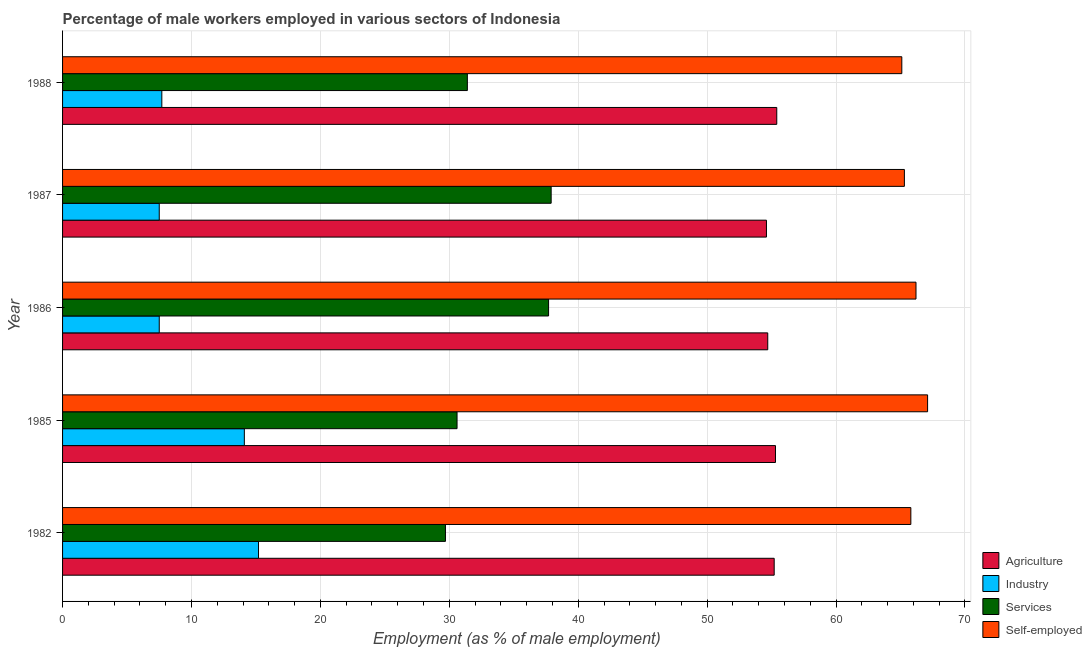How many different coloured bars are there?
Offer a very short reply. 4. Are the number of bars per tick equal to the number of legend labels?
Your response must be concise. Yes. Are the number of bars on each tick of the Y-axis equal?
Your response must be concise. Yes. How many bars are there on the 2nd tick from the bottom?
Offer a terse response. 4. What is the label of the 5th group of bars from the top?
Offer a very short reply. 1982. In how many cases, is the number of bars for a given year not equal to the number of legend labels?
Your response must be concise. 0. What is the percentage of male workers in agriculture in 1982?
Provide a succinct answer. 55.2. Across all years, what is the maximum percentage of male workers in agriculture?
Offer a very short reply. 55.4. What is the total percentage of self employed male workers in the graph?
Your answer should be compact. 329.5. What is the difference between the percentage of male workers in agriculture in 1985 and that in 1988?
Give a very brief answer. -0.1. What is the difference between the percentage of male workers in services in 1985 and the percentage of male workers in agriculture in 1986?
Provide a short and direct response. -24.1. What is the average percentage of self employed male workers per year?
Your response must be concise. 65.9. In the year 1982, what is the difference between the percentage of male workers in services and percentage of self employed male workers?
Make the answer very short. -36.1. In how many years, is the percentage of male workers in industry greater than 30 %?
Make the answer very short. 0. What is the ratio of the percentage of male workers in agriculture in 1985 to that in 1986?
Your answer should be very brief. 1.01. Is the percentage of male workers in services in 1982 less than that in 1987?
Ensure brevity in your answer.  Yes. Is the difference between the percentage of male workers in services in 1982 and 1985 greater than the difference between the percentage of male workers in agriculture in 1982 and 1985?
Your response must be concise. No. What is the difference between the highest and the second highest percentage of male workers in agriculture?
Your response must be concise. 0.1. In how many years, is the percentage of male workers in services greater than the average percentage of male workers in services taken over all years?
Offer a very short reply. 2. What does the 2nd bar from the top in 1985 represents?
Your answer should be compact. Services. What does the 4th bar from the bottom in 1987 represents?
Offer a terse response. Self-employed. Is it the case that in every year, the sum of the percentage of male workers in agriculture and percentage of male workers in industry is greater than the percentage of male workers in services?
Keep it short and to the point. Yes. Are all the bars in the graph horizontal?
Provide a succinct answer. Yes. How many years are there in the graph?
Your answer should be very brief. 5. What is the difference between two consecutive major ticks on the X-axis?
Provide a short and direct response. 10. Are the values on the major ticks of X-axis written in scientific E-notation?
Offer a very short reply. No. How many legend labels are there?
Your response must be concise. 4. How are the legend labels stacked?
Offer a terse response. Vertical. What is the title of the graph?
Make the answer very short. Percentage of male workers employed in various sectors of Indonesia. What is the label or title of the X-axis?
Offer a terse response. Employment (as % of male employment). What is the label or title of the Y-axis?
Offer a terse response. Year. What is the Employment (as % of male employment) of Agriculture in 1982?
Give a very brief answer. 55.2. What is the Employment (as % of male employment) of Industry in 1982?
Your response must be concise. 15.2. What is the Employment (as % of male employment) in Services in 1982?
Your response must be concise. 29.7. What is the Employment (as % of male employment) of Self-employed in 1982?
Offer a very short reply. 65.8. What is the Employment (as % of male employment) in Agriculture in 1985?
Make the answer very short. 55.3. What is the Employment (as % of male employment) of Industry in 1985?
Offer a terse response. 14.1. What is the Employment (as % of male employment) in Services in 1985?
Your answer should be compact. 30.6. What is the Employment (as % of male employment) in Self-employed in 1985?
Ensure brevity in your answer.  67.1. What is the Employment (as % of male employment) of Agriculture in 1986?
Keep it short and to the point. 54.7. What is the Employment (as % of male employment) of Services in 1986?
Give a very brief answer. 37.7. What is the Employment (as % of male employment) in Self-employed in 1986?
Make the answer very short. 66.2. What is the Employment (as % of male employment) in Agriculture in 1987?
Ensure brevity in your answer.  54.6. What is the Employment (as % of male employment) of Services in 1987?
Provide a short and direct response. 37.9. What is the Employment (as % of male employment) in Self-employed in 1987?
Offer a terse response. 65.3. What is the Employment (as % of male employment) of Agriculture in 1988?
Your answer should be compact. 55.4. What is the Employment (as % of male employment) of Industry in 1988?
Give a very brief answer. 7.7. What is the Employment (as % of male employment) in Services in 1988?
Offer a terse response. 31.4. What is the Employment (as % of male employment) in Self-employed in 1988?
Provide a short and direct response. 65.1. Across all years, what is the maximum Employment (as % of male employment) in Agriculture?
Offer a very short reply. 55.4. Across all years, what is the maximum Employment (as % of male employment) of Industry?
Your answer should be very brief. 15.2. Across all years, what is the maximum Employment (as % of male employment) in Services?
Your answer should be very brief. 37.9. Across all years, what is the maximum Employment (as % of male employment) in Self-employed?
Ensure brevity in your answer.  67.1. Across all years, what is the minimum Employment (as % of male employment) in Agriculture?
Keep it short and to the point. 54.6. Across all years, what is the minimum Employment (as % of male employment) of Services?
Give a very brief answer. 29.7. Across all years, what is the minimum Employment (as % of male employment) of Self-employed?
Provide a short and direct response. 65.1. What is the total Employment (as % of male employment) of Agriculture in the graph?
Offer a terse response. 275.2. What is the total Employment (as % of male employment) in Industry in the graph?
Offer a very short reply. 52. What is the total Employment (as % of male employment) of Services in the graph?
Give a very brief answer. 167.3. What is the total Employment (as % of male employment) of Self-employed in the graph?
Your response must be concise. 329.5. What is the difference between the Employment (as % of male employment) in Services in 1982 and that in 1985?
Your answer should be very brief. -0.9. What is the difference between the Employment (as % of male employment) in Agriculture in 1982 and that in 1986?
Your response must be concise. 0.5. What is the difference between the Employment (as % of male employment) in Services in 1982 and that in 1986?
Your response must be concise. -8. What is the difference between the Employment (as % of male employment) in Self-employed in 1982 and that in 1986?
Your answer should be very brief. -0.4. What is the difference between the Employment (as % of male employment) in Agriculture in 1982 and that in 1987?
Your answer should be very brief. 0.6. What is the difference between the Employment (as % of male employment) in Industry in 1982 and that in 1987?
Offer a very short reply. 7.7. What is the difference between the Employment (as % of male employment) in Self-employed in 1982 and that in 1987?
Provide a short and direct response. 0.5. What is the difference between the Employment (as % of male employment) in Industry in 1982 and that in 1988?
Your response must be concise. 7.5. What is the difference between the Employment (as % of male employment) of Self-employed in 1982 and that in 1988?
Offer a terse response. 0.7. What is the difference between the Employment (as % of male employment) in Agriculture in 1985 and that in 1986?
Offer a terse response. 0.6. What is the difference between the Employment (as % of male employment) in Services in 1985 and that in 1986?
Ensure brevity in your answer.  -7.1. What is the difference between the Employment (as % of male employment) in Self-employed in 1985 and that in 1986?
Give a very brief answer. 0.9. What is the difference between the Employment (as % of male employment) in Agriculture in 1985 and that in 1987?
Offer a very short reply. 0.7. What is the difference between the Employment (as % of male employment) in Industry in 1985 and that in 1987?
Offer a very short reply. 6.6. What is the difference between the Employment (as % of male employment) of Services in 1985 and that in 1987?
Provide a succinct answer. -7.3. What is the difference between the Employment (as % of male employment) in Self-employed in 1985 and that in 1987?
Give a very brief answer. 1.8. What is the difference between the Employment (as % of male employment) of Industry in 1985 and that in 1988?
Offer a terse response. 6.4. What is the difference between the Employment (as % of male employment) of Self-employed in 1985 and that in 1988?
Provide a succinct answer. 2. What is the difference between the Employment (as % of male employment) of Agriculture in 1986 and that in 1987?
Ensure brevity in your answer.  0.1. What is the difference between the Employment (as % of male employment) in Self-employed in 1986 and that in 1987?
Make the answer very short. 0.9. What is the difference between the Employment (as % of male employment) of Agriculture in 1986 and that in 1988?
Your response must be concise. -0.7. What is the difference between the Employment (as % of male employment) in Industry in 1986 and that in 1988?
Keep it short and to the point. -0.2. What is the difference between the Employment (as % of male employment) of Self-employed in 1986 and that in 1988?
Ensure brevity in your answer.  1.1. What is the difference between the Employment (as % of male employment) of Agriculture in 1987 and that in 1988?
Offer a very short reply. -0.8. What is the difference between the Employment (as % of male employment) of Services in 1987 and that in 1988?
Your response must be concise. 6.5. What is the difference between the Employment (as % of male employment) of Self-employed in 1987 and that in 1988?
Ensure brevity in your answer.  0.2. What is the difference between the Employment (as % of male employment) of Agriculture in 1982 and the Employment (as % of male employment) of Industry in 1985?
Make the answer very short. 41.1. What is the difference between the Employment (as % of male employment) of Agriculture in 1982 and the Employment (as % of male employment) of Services in 1985?
Keep it short and to the point. 24.6. What is the difference between the Employment (as % of male employment) of Industry in 1982 and the Employment (as % of male employment) of Services in 1985?
Your answer should be very brief. -15.4. What is the difference between the Employment (as % of male employment) in Industry in 1982 and the Employment (as % of male employment) in Self-employed in 1985?
Ensure brevity in your answer.  -51.9. What is the difference between the Employment (as % of male employment) of Services in 1982 and the Employment (as % of male employment) of Self-employed in 1985?
Provide a short and direct response. -37.4. What is the difference between the Employment (as % of male employment) in Agriculture in 1982 and the Employment (as % of male employment) in Industry in 1986?
Your answer should be very brief. 47.7. What is the difference between the Employment (as % of male employment) in Agriculture in 1982 and the Employment (as % of male employment) in Services in 1986?
Offer a terse response. 17.5. What is the difference between the Employment (as % of male employment) in Agriculture in 1982 and the Employment (as % of male employment) in Self-employed in 1986?
Provide a short and direct response. -11. What is the difference between the Employment (as % of male employment) in Industry in 1982 and the Employment (as % of male employment) in Services in 1986?
Give a very brief answer. -22.5. What is the difference between the Employment (as % of male employment) of Industry in 1982 and the Employment (as % of male employment) of Self-employed in 1986?
Your response must be concise. -51. What is the difference between the Employment (as % of male employment) in Services in 1982 and the Employment (as % of male employment) in Self-employed in 1986?
Offer a very short reply. -36.5. What is the difference between the Employment (as % of male employment) of Agriculture in 1982 and the Employment (as % of male employment) of Industry in 1987?
Your response must be concise. 47.7. What is the difference between the Employment (as % of male employment) of Agriculture in 1982 and the Employment (as % of male employment) of Services in 1987?
Your answer should be very brief. 17.3. What is the difference between the Employment (as % of male employment) in Industry in 1982 and the Employment (as % of male employment) in Services in 1987?
Ensure brevity in your answer.  -22.7. What is the difference between the Employment (as % of male employment) of Industry in 1982 and the Employment (as % of male employment) of Self-employed in 1987?
Offer a very short reply. -50.1. What is the difference between the Employment (as % of male employment) of Services in 1982 and the Employment (as % of male employment) of Self-employed in 1987?
Provide a succinct answer. -35.6. What is the difference between the Employment (as % of male employment) in Agriculture in 1982 and the Employment (as % of male employment) in Industry in 1988?
Keep it short and to the point. 47.5. What is the difference between the Employment (as % of male employment) of Agriculture in 1982 and the Employment (as % of male employment) of Services in 1988?
Your response must be concise. 23.8. What is the difference between the Employment (as % of male employment) in Agriculture in 1982 and the Employment (as % of male employment) in Self-employed in 1988?
Your answer should be very brief. -9.9. What is the difference between the Employment (as % of male employment) of Industry in 1982 and the Employment (as % of male employment) of Services in 1988?
Ensure brevity in your answer.  -16.2. What is the difference between the Employment (as % of male employment) of Industry in 1982 and the Employment (as % of male employment) of Self-employed in 1988?
Provide a succinct answer. -49.9. What is the difference between the Employment (as % of male employment) in Services in 1982 and the Employment (as % of male employment) in Self-employed in 1988?
Give a very brief answer. -35.4. What is the difference between the Employment (as % of male employment) of Agriculture in 1985 and the Employment (as % of male employment) of Industry in 1986?
Provide a short and direct response. 47.8. What is the difference between the Employment (as % of male employment) of Agriculture in 1985 and the Employment (as % of male employment) of Services in 1986?
Offer a terse response. 17.6. What is the difference between the Employment (as % of male employment) in Industry in 1985 and the Employment (as % of male employment) in Services in 1986?
Your response must be concise. -23.6. What is the difference between the Employment (as % of male employment) in Industry in 1985 and the Employment (as % of male employment) in Self-employed in 1986?
Give a very brief answer. -52.1. What is the difference between the Employment (as % of male employment) of Services in 1985 and the Employment (as % of male employment) of Self-employed in 1986?
Make the answer very short. -35.6. What is the difference between the Employment (as % of male employment) in Agriculture in 1985 and the Employment (as % of male employment) in Industry in 1987?
Ensure brevity in your answer.  47.8. What is the difference between the Employment (as % of male employment) of Agriculture in 1985 and the Employment (as % of male employment) of Self-employed in 1987?
Your answer should be very brief. -10. What is the difference between the Employment (as % of male employment) in Industry in 1985 and the Employment (as % of male employment) in Services in 1987?
Make the answer very short. -23.8. What is the difference between the Employment (as % of male employment) of Industry in 1985 and the Employment (as % of male employment) of Self-employed in 1987?
Offer a very short reply. -51.2. What is the difference between the Employment (as % of male employment) in Services in 1985 and the Employment (as % of male employment) in Self-employed in 1987?
Give a very brief answer. -34.7. What is the difference between the Employment (as % of male employment) in Agriculture in 1985 and the Employment (as % of male employment) in Industry in 1988?
Your response must be concise. 47.6. What is the difference between the Employment (as % of male employment) of Agriculture in 1985 and the Employment (as % of male employment) of Services in 1988?
Ensure brevity in your answer.  23.9. What is the difference between the Employment (as % of male employment) of Agriculture in 1985 and the Employment (as % of male employment) of Self-employed in 1988?
Make the answer very short. -9.8. What is the difference between the Employment (as % of male employment) of Industry in 1985 and the Employment (as % of male employment) of Services in 1988?
Make the answer very short. -17.3. What is the difference between the Employment (as % of male employment) of Industry in 1985 and the Employment (as % of male employment) of Self-employed in 1988?
Give a very brief answer. -51. What is the difference between the Employment (as % of male employment) of Services in 1985 and the Employment (as % of male employment) of Self-employed in 1988?
Your answer should be very brief. -34.5. What is the difference between the Employment (as % of male employment) of Agriculture in 1986 and the Employment (as % of male employment) of Industry in 1987?
Provide a succinct answer. 47.2. What is the difference between the Employment (as % of male employment) in Agriculture in 1986 and the Employment (as % of male employment) in Services in 1987?
Your response must be concise. 16.8. What is the difference between the Employment (as % of male employment) of Agriculture in 1986 and the Employment (as % of male employment) of Self-employed in 1987?
Ensure brevity in your answer.  -10.6. What is the difference between the Employment (as % of male employment) of Industry in 1986 and the Employment (as % of male employment) of Services in 1987?
Offer a very short reply. -30.4. What is the difference between the Employment (as % of male employment) in Industry in 1986 and the Employment (as % of male employment) in Self-employed in 1987?
Offer a terse response. -57.8. What is the difference between the Employment (as % of male employment) of Services in 1986 and the Employment (as % of male employment) of Self-employed in 1987?
Your response must be concise. -27.6. What is the difference between the Employment (as % of male employment) of Agriculture in 1986 and the Employment (as % of male employment) of Industry in 1988?
Provide a succinct answer. 47. What is the difference between the Employment (as % of male employment) of Agriculture in 1986 and the Employment (as % of male employment) of Services in 1988?
Make the answer very short. 23.3. What is the difference between the Employment (as % of male employment) in Industry in 1986 and the Employment (as % of male employment) in Services in 1988?
Offer a terse response. -23.9. What is the difference between the Employment (as % of male employment) in Industry in 1986 and the Employment (as % of male employment) in Self-employed in 1988?
Provide a short and direct response. -57.6. What is the difference between the Employment (as % of male employment) of Services in 1986 and the Employment (as % of male employment) of Self-employed in 1988?
Provide a short and direct response. -27.4. What is the difference between the Employment (as % of male employment) of Agriculture in 1987 and the Employment (as % of male employment) of Industry in 1988?
Ensure brevity in your answer.  46.9. What is the difference between the Employment (as % of male employment) in Agriculture in 1987 and the Employment (as % of male employment) in Services in 1988?
Your answer should be very brief. 23.2. What is the difference between the Employment (as % of male employment) of Agriculture in 1987 and the Employment (as % of male employment) of Self-employed in 1988?
Your response must be concise. -10.5. What is the difference between the Employment (as % of male employment) in Industry in 1987 and the Employment (as % of male employment) in Services in 1988?
Ensure brevity in your answer.  -23.9. What is the difference between the Employment (as % of male employment) in Industry in 1987 and the Employment (as % of male employment) in Self-employed in 1988?
Give a very brief answer. -57.6. What is the difference between the Employment (as % of male employment) of Services in 1987 and the Employment (as % of male employment) of Self-employed in 1988?
Give a very brief answer. -27.2. What is the average Employment (as % of male employment) in Agriculture per year?
Your answer should be compact. 55.04. What is the average Employment (as % of male employment) in Industry per year?
Give a very brief answer. 10.4. What is the average Employment (as % of male employment) of Services per year?
Your answer should be compact. 33.46. What is the average Employment (as % of male employment) in Self-employed per year?
Your response must be concise. 65.9. In the year 1982, what is the difference between the Employment (as % of male employment) of Industry and Employment (as % of male employment) of Self-employed?
Provide a succinct answer. -50.6. In the year 1982, what is the difference between the Employment (as % of male employment) in Services and Employment (as % of male employment) in Self-employed?
Ensure brevity in your answer.  -36.1. In the year 1985, what is the difference between the Employment (as % of male employment) in Agriculture and Employment (as % of male employment) in Industry?
Your response must be concise. 41.2. In the year 1985, what is the difference between the Employment (as % of male employment) of Agriculture and Employment (as % of male employment) of Services?
Your response must be concise. 24.7. In the year 1985, what is the difference between the Employment (as % of male employment) in Industry and Employment (as % of male employment) in Services?
Offer a very short reply. -16.5. In the year 1985, what is the difference between the Employment (as % of male employment) of Industry and Employment (as % of male employment) of Self-employed?
Make the answer very short. -53. In the year 1985, what is the difference between the Employment (as % of male employment) in Services and Employment (as % of male employment) in Self-employed?
Your response must be concise. -36.5. In the year 1986, what is the difference between the Employment (as % of male employment) in Agriculture and Employment (as % of male employment) in Industry?
Offer a very short reply. 47.2. In the year 1986, what is the difference between the Employment (as % of male employment) of Agriculture and Employment (as % of male employment) of Services?
Your answer should be compact. 17. In the year 1986, what is the difference between the Employment (as % of male employment) in Agriculture and Employment (as % of male employment) in Self-employed?
Keep it short and to the point. -11.5. In the year 1986, what is the difference between the Employment (as % of male employment) of Industry and Employment (as % of male employment) of Services?
Provide a succinct answer. -30.2. In the year 1986, what is the difference between the Employment (as % of male employment) of Industry and Employment (as % of male employment) of Self-employed?
Your response must be concise. -58.7. In the year 1986, what is the difference between the Employment (as % of male employment) of Services and Employment (as % of male employment) of Self-employed?
Your answer should be compact. -28.5. In the year 1987, what is the difference between the Employment (as % of male employment) in Agriculture and Employment (as % of male employment) in Industry?
Your answer should be compact. 47.1. In the year 1987, what is the difference between the Employment (as % of male employment) of Agriculture and Employment (as % of male employment) of Self-employed?
Offer a very short reply. -10.7. In the year 1987, what is the difference between the Employment (as % of male employment) in Industry and Employment (as % of male employment) in Services?
Your answer should be very brief. -30.4. In the year 1987, what is the difference between the Employment (as % of male employment) in Industry and Employment (as % of male employment) in Self-employed?
Offer a terse response. -57.8. In the year 1987, what is the difference between the Employment (as % of male employment) of Services and Employment (as % of male employment) of Self-employed?
Your response must be concise. -27.4. In the year 1988, what is the difference between the Employment (as % of male employment) in Agriculture and Employment (as % of male employment) in Industry?
Give a very brief answer. 47.7. In the year 1988, what is the difference between the Employment (as % of male employment) of Agriculture and Employment (as % of male employment) of Services?
Keep it short and to the point. 24. In the year 1988, what is the difference between the Employment (as % of male employment) in Industry and Employment (as % of male employment) in Services?
Your answer should be very brief. -23.7. In the year 1988, what is the difference between the Employment (as % of male employment) of Industry and Employment (as % of male employment) of Self-employed?
Your answer should be very brief. -57.4. In the year 1988, what is the difference between the Employment (as % of male employment) of Services and Employment (as % of male employment) of Self-employed?
Ensure brevity in your answer.  -33.7. What is the ratio of the Employment (as % of male employment) in Agriculture in 1982 to that in 1985?
Your response must be concise. 1. What is the ratio of the Employment (as % of male employment) in Industry in 1982 to that in 1985?
Make the answer very short. 1.08. What is the ratio of the Employment (as % of male employment) of Services in 1982 to that in 1985?
Ensure brevity in your answer.  0.97. What is the ratio of the Employment (as % of male employment) in Self-employed in 1982 to that in 1985?
Make the answer very short. 0.98. What is the ratio of the Employment (as % of male employment) of Agriculture in 1982 to that in 1986?
Your answer should be compact. 1.01. What is the ratio of the Employment (as % of male employment) in Industry in 1982 to that in 1986?
Your answer should be compact. 2.03. What is the ratio of the Employment (as % of male employment) of Services in 1982 to that in 1986?
Your response must be concise. 0.79. What is the ratio of the Employment (as % of male employment) in Self-employed in 1982 to that in 1986?
Your answer should be compact. 0.99. What is the ratio of the Employment (as % of male employment) in Industry in 1982 to that in 1987?
Ensure brevity in your answer.  2.03. What is the ratio of the Employment (as % of male employment) of Services in 1982 to that in 1987?
Your response must be concise. 0.78. What is the ratio of the Employment (as % of male employment) of Self-employed in 1982 to that in 1987?
Offer a very short reply. 1.01. What is the ratio of the Employment (as % of male employment) of Industry in 1982 to that in 1988?
Your answer should be very brief. 1.97. What is the ratio of the Employment (as % of male employment) of Services in 1982 to that in 1988?
Keep it short and to the point. 0.95. What is the ratio of the Employment (as % of male employment) of Self-employed in 1982 to that in 1988?
Keep it short and to the point. 1.01. What is the ratio of the Employment (as % of male employment) in Agriculture in 1985 to that in 1986?
Ensure brevity in your answer.  1.01. What is the ratio of the Employment (as % of male employment) of Industry in 1985 to that in 1986?
Ensure brevity in your answer.  1.88. What is the ratio of the Employment (as % of male employment) of Services in 1985 to that in 1986?
Ensure brevity in your answer.  0.81. What is the ratio of the Employment (as % of male employment) in Self-employed in 1985 to that in 1986?
Ensure brevity in your answer.  1.01. What is the ratio of the Employment (as % of male employment) of Agriculture in 1985 to that in 1987?
Your response must be concise. 1.01. What is the ratio of the Employment (as % of male employment) in Industry in 1985 to that in 1987?
Your response must be concise. 1.88. What is the ratio of the Employment (as % of male employment) in Services in 1985 to that in 1987?
Give a very brief answer. 0.81. What is the ratio of the Employment (as % of male employment) in Self-employed in 1985 to that in 1987?
Offer a terse response. 1.03. What is the ratio of the Employment (as % of male employment) in Industry in 1985 to that in 1988?
Ensure brevity in your answer.  1.83. What is the ratio of the Employment (as % of male employment) of Services in 1985 to that in 1988?
Give a very brief answer. 0.97. What is the ratio of the Employment (as % of male employment) of Self-employed in 1985 to that in 1988?
Ensure brevity in your answer.  1.03. What is the ratio of the Employment (as % of male employment) of Services in 1986 to that in 1987?
Make the answer very short. 0.99. What is the ratio of the Employment (as % of male employment) of Self-employed in 1986 to that in 1987?
Ensure brevity in your answer.  1.01. What is the ratio of the Employment (as % of male employment) in Agriculture in 1986 to that in 1988?
Your answer should be very brief. 0.99. What is the ratio of the Employment (as % of male employment) in Services in 1986 to that in 1988?
Offer a terse response. 1.2. What is the ratio of the Employment (as % of male employment) of Self-employed in 1986 to that in 1988?
Make the answer very short. 1.02. What is the ratio of the Employment (as % of male employment) in Agriculture in 1987 to that in 1988?
Make the answer very short. 0.99. What is the ratio of the Employment (as % of male employment) of Services in 1987 to that in 1988?
Ensure brevity in your answer.  1.21. What is the ratio of the Employment (as % of male employment) of Self-employed in 1987 to that in 1988?
Provide a succinct answer. 1. What is the difference between the highest and the second highest Employment (as % of male employment) of Agriculture?
Your response must be concise. 0.1. What is the difference between the highest and the second highest Employment (as % of male employment) in Industry?
Ensure brevity in your answer.  1.1. What is the difference between the highest and the second highest Employment (as % of male employment) of Self-employed?
Make the answer very short. 0.9. What is the difference between the highest and the lowest Employment (as % of male employment) of Agriculture?
Ensure brevity in your answer.  0.8. What is the difference between the highest and the lowest Employment (as % of male employment) of Services?
Provide a succinct answer. 8.2. What is the difference between the highest and the lowest Employment (as % of male employment) in Self-employed?
Make the answer very short. 2. 